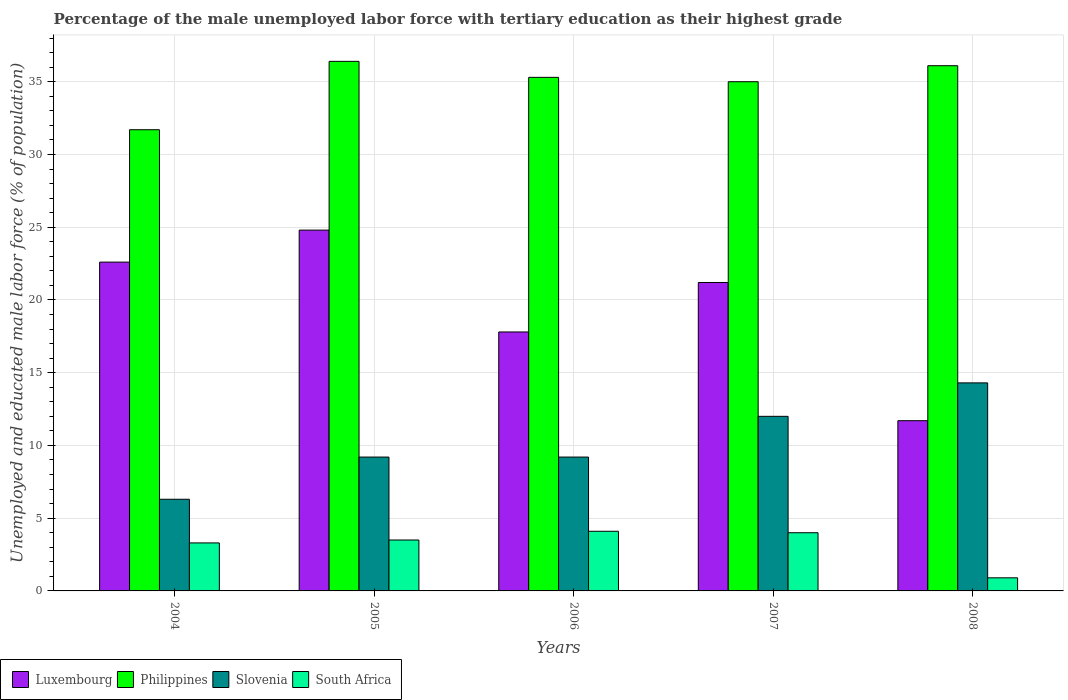How many different coloured bars are there?
Provide a succinct answer. 4. How many groups of bars are there?
Offer a very short reply. 5. Are the number of bars per tick equal to the number of legend labels?
Offer a terse response. Yes. How many bars are there on the 5th tick from the right?
Offer a very short reply. 4. What is the percentage of the unemployed male labor force with tertiary education in Luxembourg in 2004?
Give a very brief answer. 22.6. Across all years, what is the maximum percentage of the unemployed male labor force with tertiary education in Slovenia?
Keep it short and to the point. 14.3. Across all years, what is the minimum percentage of the unemployed male labor force with tertiary education in Slovenia?
Provide a succinct answer. 6.3. In which year was the percentage of the unemployed male labor force with tertiary education in Philippines minimum?
Your response must be concise. 2004. What is the total percentage of the unemployed male labor force with tertiary education in Slovenia in the graph?
Offer a very short reply. 51. What is the difference between the percentage of the unemployed male labor force with tertiary education in Slovenia in 2007 and that in 2008?
Offer a very short reply. -2.3. What is the difference between the percentage of the unemployed male labor force with tertiary education in Philippines in 2005 and the percentage of the unemployed male labor force with tertiary education in South Africa in 2006?
Your response must be concise. 32.3. What is the average percentage of the unemployed male labor force with tertiary education in South Africa per year?
Keep it short and to the point. 3.16. In the year 2006, what is the difference between the percentage of the unemployed male labor force with tertiary education in Luxembourg and percentage of the unemployed male labor force with tertiary education in Philippines?
Offer a terse response. -17.5. In how many years, is the percentage of the unemployed male labor force with tertiary education in Philippines greater than 28 %?
Your response must be concise. 5. What is the ratio of the percentage of the unemployed male labor force with tertiary education in Luxembourg in 2006 to that in 2007?
Your answer should be compact. 0.84. What is the difference between the highest and the second highest percentage of the unemployed male labor force with tertiary education in Slovenia?
Ensure brevity in your answer.  2.3. What is the difference between the highest and the lowest percentage of the unemployed male labor force with tertiary education in Philippines?
Offer a terse response. 4.7. In how many years, is the percentage of the unemployed male labor force with tertiary education in South Africa greater than the average percentage of the unemployed male labor force with tertiary education in South Africa taken over all years?
Provide a short and direct response. 4. Is it the case that in every year, the sum of the percentage of the unemployed male labor force with tertiary education in Luxembourg and percentage of the unemployed male labor force with tertiary education in South Africa is greater than the sum of percentage of the unemployed male labor force with tertiary education in Slovenia and percentage of the unemployed male labor force with tertiary education in Philippines?
Your answer should be very brief. No. What does the 2nd bar from the left in 2005 represents?
Keep it short and to the point. Philippines. What does the 2nd bar from the right in 2004 represents?
Keep it short and to the point. Slovenia. How many legend labels are there?
Provide a succinct answer. 4. What is the title of the graph?
Make the answer very short. Percentage of the male unemployed labor force with tertiary education as their highest grade. What is the label or title of the Y-axis?
Ensure brevity in your answer.  Unemployed and educated male labor force (% of population). What is the Unemployed and educated male labor force (% of population) of Luxembourg in 2004?
Offer a terse response. 22.6. What is the Unemployed and educated male labor force (% of population) of Philippines in 2004?
Provide a short and direct response. 31.7. What is the Unemployed and educated male labor force (% of population) of Slovenia in 2004?
Your response must be concise. 6.3. What is the Unemployed and educated male labor force (% of population) in South Africa in 2004?
Your answer should be very brief. 3.3. What is the Unemployed and educated male labor force (% of population) in Luxembourg in 2005?
Offer a very short reply. 24.8. What is the Unemployed and educated male labor force (% of population) in Philippines in 2005?
Keep it short and to the point. 36.4. What is the Unemployed and educated male labor force (% of population) in Slovenia in 2005?
Your response must be concise. 9.2. What is the Unemployed and educated male labor force (% of population) of Luxembourg in 2006?
Make the answer very short. 17.8. What is the Unemployed and educated male labor force (% of population) in Philippines in 2006?
Your response must be concise. 35.3. What is the Unemployed and educated male labor force (% of population) of Slovenia in 2006?
Give a very brief answer. 9.2. What is the Unemployed and educated male labor force (% of population) in South Africa in 2006?
Provide a succinct answer. 4.1. What is the Unemployed and educated male labor force (% of population) of Luxembourg in 2007?
Your answer should be compact. 21.2. What is the Unemployed and educated male labor force (% of population) in Philippines in 2007?
Your answer should be compact. 35. What is the Unemployed and educated male labor force (% of population) of South Africa in 2007?
Offer a terse response. 4. What is the Unemployed and educated male labor force (% of population) of Luxembourg in 2008?
Keep it short and to the point. 11.7. What is the Unemployed and educated male labor force (% of population) of Philippines in 2008?
Offer a very short reply. 36.1. What is the Unemployed and educated male labor force (% of population) of Slovenia in 2008?
Ensure brevity in your answer.  14.3. What is the Unemployed and educated male labor force (% of population) of South Africa in 2008?
Provide a succinct answer. 0.9. Across all years, what is the maximum Unemployed and educated male labor force (% of population) in Luxembourg?
Give a very brief answer. 24.8. Across all years, what is the maximum Unemployed and educated male labor force (% of population) in Philippines?
Offer a terse response. 36.4. Across all years, what is the maximum Unemployed and educated male labor force (% of population) in Slovenia?
Ensure brevity in your answer.  14.3. Across all years, what is the maximum Unemployed and educated male labor force (% of population) in South Africa?
Offer a terse response. 4.1. Across all years, what is the minimum Unemployed and educated male labor force (% of population) in Luxembourg?
Keep it short and to the point. 11.7. Across all years, what is the minimum Unemployed and educated male labor force (% of population) of Philippines?
Ensure brevity in your answer.  31.7. Across all years, what is the minimum Unemployed and educated male labor force (% of population) of Slovenia?
Your answer should be compact. 6.3. Across all years, what is the minimum Unemployed and educated male labor force (% of population) of South Africa?
Your answer should be very brief. 0.9. What is the total Unemployed and educated male labor force (% of population) of Luxembourg in the graph?
Your answer should be compact. 98.1. What is the total Unemployed and educated male labor force (% of population) in Philippines in the graph?
Keep it short and to the point. 174.5. What is the total Unemployed and educated male labor force (% of population) of Slovenia in the graph?
Provide a short and direct response. 51. What is the total Unemployed and educated male labor force (% of population) of South Africa in the graph?
Your answer should be very brief. 15.8. What is the difference between the Unemployed and educated male labor force (% of population) of Luxembourg in 2004 and that in 2005?
Your response must be concise. -2.2. What is the difference between the Unemployed and educated male labor force (% of population) of Philippines in 2004 and that in 2006?
Provide a short and direct response. -3.6. What is the difference between the Unemployed and educated male labor force (% of population) of Slovenia in 2004 and that in 2006?
Give a very brief answer. -2.9. What is the difference between the Unemployed and educated male labor force (% of population) in South Africa in 2004 and that in 2006?
Provide a short and direct response. -0.8. What is the difference between the Unemployed and educated male labor force (% of population) of Luxembourg in 2004 and that in 2007?
Provide a succinct answer. 1.4. What is the difference between the Unemployed and educated male labor force (% of population) in Slovenia in 2004 and that in 2007?
Keep it short and to the point. -5.7. What is the difference between the Unemployed and educated male labor force (% of population) in Luxembourg in 2004 and that in 2008?
Ensure brevity in your answer.  10.9. What is the difference between the Unemployed and educated male labor force (% of population) in Slovenia in 2004 and that in 2008?
Give a very brief answer. -8. What is the difference between the Unemployed and educated male labor force (% of population) of South Africa in 2004 and that in 2008?
Offer a very short reply. 2.4. What is the difference between the Unemployed and educated male labor force (% of population) of Slovenia in 2005 and that in 2006?
Your answer should be compact. 0. What is the difference between the Unemployed and educated male labor force (% of population) in Slovenia in 2005 and that in 2007?
Your answer should be compact. -2.8. What is the difference between the Unemployed and educated male labor force (% of population) of South Africa in 2005 and that in 2007?
Ensure brevity in your answer.  -0.5. What is the difference between the Unemployed and educated male labor force (% of population) in Luxembourg in 2005 and that in 2008?
Provide a succinct answer. 13.1. What is the difference between the Unemployed and educated male labor force (% of population) in Philippines in 2005 and that in 2008?
Give a very brief answer. 0.3. What is the difference between the Unemployed and educated male labor force (% of population) of Slovenia in 2005 and that in 2008?
Offer a very short reply. -5.1. What is the difference between the Unemployed and educated male labor force (% of population) in Luxembourg in 2006 and that in 2007?
Ensure brevity in your answer.  -3.4. What is the difference between the Unemployed and educated male labor force (% of population) of Philippines in 2006 and that in 2007?
Keep it short and to the point. 0.3. What is the difference between the Unemployed and educated male labor force (% of population) of Luxembourg in 2006 and that in 2008?
Your answer should be very brief. 6.1. What is the difference between the Unemployed and educated male labor force (% of population) in Philippines in 2006 and that in 2008?
Offer a terse response. -0.8. What is the difference between the Unemployed and educated male labor force (% of population) of Luxembourg in 2007 and that in 2008?
Ensure brevity in your answer.  9.5. What is the difference between the Unemployed and educated male labor force (% of population) of Philippines in 2007 and that in 2008?
Your answer should be compact. -1.1. What is the difference between the Unemployed and educated male labor force (% of population) of South Africa in 2007 and that in 2008?
Make the answer very short. 3.1. What is the difference between the Unemployed and educated male labor force (% of population) of Luxembourg in 2004 and the Unemployed and educated male labor force (% of population) of Slovenia in 2005?
Make the answer very short. 13.4. What is the difference between the Unemployed and educated male labor force (% of population) in Philippines in 2004 and the Unemployed and educated male labor force (% of population) in South Africa in 2005?
Provide a succinct answer. 28.2. What is the difference between the Unemployed and educated male labor force (% of population) of Luxembourg in 2004 and the Unemployed and educated male labor force (% of population) of Slovenia in 2006?
Your answer should be compact. 13.4. What is the difference between the Unemployed and educated male labor force (% of population) of Luxembourg in 2004 and the Unemployed and educated male labor force (% of population) of South Africa in 2006?
Offer a very short reply. 18.5. What is the difference between the Unemployed and educated male labor force (% of population) in Philippines in 2004 and the Unemployed and educated male labor force (% of population) in Slovenia in 2006?
Your answer should be compact. 22.5. What is the difference between the Unemployed and educated male labor force (% of population) of Philippines in 2004 and the Unemployed and educated male labor force (% of population) of South Africa in 2006?
Your response must be concise. 27.6. What is the difference between the Unemployed and educated male labor force (% of population) of Slovenia in 2004 and the Unemployed and educated male labor force (% of population) of South Africa in 2006?
Ensure brevity in your answer.  2.2. What is the difference between the Unemployed and educated male labor force (% of population) of Luxembourg in 2004 and the Unemployed and educated male labor force (% of population) of Philippines in 2007?
Keep it short and to the point. -12.4. What is the difference between the Unemployed and educated male labor force (% of population) in Philippines in 2004 and the Unemployed and educated male labor force (% of population) in South Africa in 2007?
Offer a terse response. 27.7. What is the difference between the Unemployed and educated male labor force (% of population) in Luxembourg in 2004 and the Unemployed and educated male labor force (% of population) in Slovenia in 2008?
Your response must be concise. 8.3. What is the difference between the Unemployed and educated male labor force (% of population) in Luxembourg in 2004 and the Unemployed and educated male labor force (% of population) in South Africa in 2008?
Offer a terse response. 21.7. What is the difference between the Unemployed and educated male labor force (% of population) of Philippines in 2004 and the Unemployed and educated male labor force (% of population) of South Africa in 2008?
Offer a terse response. 30.8. What is the difference between the Unemployed and educated male labor force (% of population) in Luxembourg in 2005 and the Unemployed and educated male labor force (% of population) in Slovenia in 2006?
Offer a very short reply. 15.6. What is the difference between the Unemployed and educated male labor force (% of population) in Luxembourg in 2005 and the Unemployed and educated male labor force (% of population) in South Africa in 2006?
Provide a succinct answer. 20.7. What is the difference between the Unemployed and educated male labor force (% of population) of Philippines in 2005 and the Unemployed and educated male labor force (% of population) of Slovenia in 2006?
Provide a short and direct response. 27.2. What is the difference between the Unemployed and educated male labor force (% of population) of Philippines in 2005 and the Unemployed and educated male labor force (% of population) of South Africa in 2006?
Keep it short and to the point. 32.3. What is the difference between the Unemployed and educated male labor force (% of population) in Slovenia in 2005 and the Unemployed and educated male labor force (% of population) in South Africa in 2006?
Your answer should be compact. 5.1. What is the difference between the Unemployed and educated male labor force (% of population) of Luxembourg in 2005 and the Unemployed and educated male labor force (% of population) of Philippines in 2007?
Your answer should be very brief. -10.2. What is the difference between the Unemployed and educated male labor force (% of population) of Luxembourg in 2005 and the Unemployed and educated male labor force (% of population) of Slovenia in 2007?
Ensure brevity in your answer.  12.8. What is the difference between the Unemployed and educated male labor force (% of population) in Luxembourg in 2005 and the Unemployed and educated male labor force (% of population) in South Africa in 2007?
Your response must be concise. 20.8. What is the difference between the Unemployed and educated male labor force (% of population) in Philippines in 2005 and the Unemployed and educated male labor force (% of population) in Slovenia in 2007?
Provide a succinct answer. 24.4. What is the difference between the Unemployed and educated male labor force (% of population) in Philippines in 2005 and the Unemployed and educated male labor force (% of population) in South Africa in 2007?
Make the answer very short. 32.4. What is the difference between the Unemployed and educated male labor force (% of population) of Slovenia in 2005 and the Unemployed and educated male labor force (% of population) of South Africa in 2007?
Provide a short and direct response. 5.2. What is the difference between the Unemployed and educated male labor force (% of population) in Luxembourg in 2005 and the Unemployed and educated male labor force (% of population) in South Africa in 2008?
Offer a very short reply. 23.9. What is the difference between the Unemployed and educated male labor force (% of population) of Philippines in 2005 and the Unemployed and educated male labor force (% of population) of Slovenia in 2008?
Ensure brevity in your answer.  22.1. What is the difference between the Unemployed and educated male labor force (% of population) in Philippines in 2005 and the Unemployed and educated male labor force (% of population) in South Africa in 2008?
Give a very brief answer. 35.5. What is the difference between the Unemployed and educated male labor force (% of population) of Slovenia in 2005 and the Unemployed and educated male labor force (% of population) of South Africa in 2008?
Offer a very short reply. 8.3. What is the difference between the Unemployed and educated male labor force (% of population) in Luxembourg in 2006 and the Unemployed and educated male labor force (% of population) in Philippines in 2007?
Offer a terse response. -17.2. What is the difference between the Unemployed and educated male labor force (% of population) in Luxembourg in 2006 and the Unemployed and educated male labor force (% of population) in Slovenia in 2007?
Your answer should be compact. 5.8. What is the difference between the Unemployed and educated male labor force (% of population) of Luxembourg in 2006 and the Unemployed and educated male labor force (% of population) of South Africa in 2007?
Provide a succinct answer. 13.8. What is the difference between the Unemployed and educated male labor force (% of population) of Philippines in 2006 and the Unemployed and educated male labor force (% of population) of Slovenia in 2007?
Offer a terse response. 23.3. What is the difference between the Unemployed and educated male labor force (% of population) in Philippines in 2006 and the Unemployed and educated male labor force (% of population) in South Africa in 2007?
Provide a succinct answer. 31.3. What is the difference between the Unemployed and educated male labor force (% of population) in Luxembourg in 2006 and the Unemployed and educated male labor force (% of population) in Philippines in 2008?
Your answer should be very brief. -18.3. What is the difference between the Unemployed and educated male labor force (% of population) in Luxembourg in 2006 and the Unemployed and educated male labor force (% of population) in Slovenia in 2008?
Give a very brief answer. 3.5. What is the difference between the Unemployed and educated male labor force (% of population) of Philippines in 2006 and the Unemployed and educated male labor force (% of population) of Slovenia in 2008?
Provide a short and direct response. 21. What is the difference between the Unemployed and educated male labor force (% of population) in Philippines in 2006 and the Unemployed and educated male labor force (% of population) in South Africa in 2008?
Provide a short and direct response. 34.4. What is the difference between the Unemployed and educated male labor force (% of population) of Luxembourg in 2007 and the Unemployed and educated male labor force (% of population) of Philippines in 2008?
Give a very brief answer. -14.9. What is the difference between the Unemployed and educated male labor force (% of population) of Luxembourg in 2007 and the Unemployed and educated male labor force (% of population) of Slovenia in 2008?
Your response must be concise. 6.9. What is the difference between the Unemployed and educated male labor force (% of population) in Luxembourg in 2007 and the Unemployed and educated male labor force (% of population) in South Africa in 2008?
Provide a succinct answer. 20.3. What is the difference between the Unemployed and educated male labor force (% of population) of Philippines in 2007 and the Unemployed and educated male labor force (% of population) of Slovenia in 2008?
Offer a very short reply. 20.7. What is the difference between the Unemployed and educated male labor force (% of population) in Philippines in 2007 and the Unemployed and educated male labor force (% of population) in South Africa in 2008?
Provide a succinct answer. 34.1. What is the average Unemployed and educated male labor force (% of population) of Luxembourg per year?
Your answer should be compact. 19.62. What is the average Unemployed and educated male labor force (% of population) in Philippines per year?
Provide a short and direct response. 34.9. What is the average Unemployed and educated male labor force (% of population) in South Africa per year?
Give a very brief answer. 3.16. In the year 2004, what is the difference between the Unemployed and educated male labor force (% of population) in Luxembourg and Unemployed and educated male labor force (% of population) in South Africa?
Your answer should be compact. 19.3. In the year 2004, what is the difference between the Unemployed and educated male labor force (% of population) of Philippines and Unemployed and educated male labor force (% of population) of Slovenia?
Your answer should be very brief. 25.4. In the year 2004, what is the difference between the Unemployed and educated male labor force (% of population) in Philippines and Unemployed and educated male labor force (% of population) in South Africa?
Keep it short and to the point. 28.4. In the year 2004, what is the difference between the Unemployed and educated male labor force (% of population) of Slovenia and Unemployed and educated male labor force (% of population) of South Africa?
Offer a very short reply. 3. In the year 2005, what is the difference between the Unemployed and educated male labor force (% of population) of Luxembourg and Unemployed and educated male labor force (% of population) of Philippines?
Make the answer very short. -11.6. In the year 2005, what is the difference between the Unemployed and educated male labor force (% of population) in Luxembourg and Unemployed and educated male labor force (% of population) in South Africa?
Provide a succinct answer. 21.3. In the year 2005, what is the difference between the Unemployed and educated male labor force (% of population) in Philippines and Unemployed and educated male labor force (% of population) in Slovenia?
Your answer should be compact. 27.2. In the year 2005, what is the difference between the Unemployed and educated male labor force (% of population) of Philippines and Unemployed and educated male labor force (% of population) of South Africa?
Make the answer very short. 32.9. In the year 2005, what is the difference between the Unemployed and educated male labor force (% of population) in Slovenia and Unemployed and educated male labor force (% of population) in South Africa?
Keep it short and to the point. 5.7. In the year 2006, what is the difference between the Unemployed and educated male labor force (% of population) of Luxembourg and Unemployed and educated male labor force (% of population) of Philippines?
Make the answer very short. -17.5. In the year 2006, what is the difference between the Unemployed and educated male labor force (% of population) in Luxembourg and Unemployed and educated male labor force (% of population) in Slovenia?
Give a very brief answer. 8.6. In the year 2006, what is the difference between the Unemployed and educated male labor force (% of population) of Philippines and Unemployed and educated male labor force (% of population) of Slovenia?
Provide a succinct answer. 26.1. In the year 2006, what is the difference between the Unemployed and educated male labor force (% of population) of Philippines and Unemployed and educated male labor force (% of population) of South Africa?
Keep it short and to the point. 31.2. In the year 2006, what is the difference between the Unemployed and educated male labor force (% of population) of Slovenia and Unemployed and educated male labor force (% of population) of South Africa?
Your answer should be compact. 5.1. In the year 2007, what is the difference between the Unemployed and educated male labor force (% of population) in Luxembourg and Unemployed and educated male labor force (% of population) in Philippines?
Your answer should be very brief. -13.8. In the year 2007, what is the difference between the Unemployed and educated male labor force (% of population) in Luxembourg and Unemployed and educated male labor force (% of population) in Slovenia?
Your answer should be compact. 9.2. In the year 2007, what is the difference between the Unemployed and educated male labor force (% of population) of Philippines and Unemployed and educated male labor force (% of population) of Slovenia?
Offer a very short reply. 23. In the year 2007, what is the difference between the Unemployed and educated male labor force (% of population) of Philippines and Unemployed and educated male labor force (% of population) of South Africa?
Your response must be concise. 31. In the year 2008, what is the difference between the Unemployed and educated male labor force (% of population) of Luxembourg and Unemployed and educated male labor force (% of population) of Philippines?
Provide a succinct answer. -24.4. In the year 2008, what is the difference between the Unemployed and educated male labor force (% of population) in Philippines and Unemployed and educated male labor force (% of population) in Slovenia?
Your answer should be compact. 21.8. In the year 2008, what is the difference between the Unemployed and educated male labor force (% of population) of Philippines and Unemployed and educated male labor force (% of population) of South Africa?
Provide a succinct answer. 35.2. In the year 2008, what is the difference between the Unemployed and educated male labor force (% of population) of Slovenia and Unemployed and educated male labor force (% of population) of South Africa?
Keep it short and to the point. 13.4. What is the ratio of the Unemployed and educated male labor force (% of population) in Luxembourg in 2004 to that in 2005?
Offer a terse response. 0.91. What is the ratio of the Unemployed and educated male labor force (% of population) in Philippines in 2004 to that in 2005?
Your answer should be very brief. 0.87. What is the ratio of the Unemployed and educated male labor force (% of population) in Slovenia in 2004 to that in 2005?
Your answer should be very brief. 0.68. What is the ratio of the Unemployed and educated male labor force (% of population) of South Africa in 2004 to that in 2005?
Give a very brief answer. 0.94. What is the ratio of the Unemployed and educated male labor force (% of population) of Luxembourg in 2004 to that in 2006?
Offer a terse response. 1.27. What is the ratio of the Unemployed and educated male labor force (% of population) in Philippines in 2004 to that in 2006?
Offer a very short reply. 0.9. What is the ratio of the Unemployed and educated male labor force (% of population) in Slovenia in 2004 to that in 2006?
Your answer should be very brief. 0.68. What is the ratio of the Unemployed and educated male labor force (% of population) of South Africa in 2004 to that in 2006?
Your answer should be compact. 0.8. What is the ratio of the Unemployed and educated male labor force (% of population) of Luxembourg in 2004 to that in 2007?
Provide a short and direct response. 1.07. What is the ratio of the Unemployed and educated male labor force (% of population) of Philippines in 2004 to that in 2007?
Your answer should be very brief. 0.91. What is the ratio of the Unemployed and educated male labor force (% of population) in Slovenia in 2004 to that in 2007?
Offer a terse response. 0.53. What is the ratio of the Unemployed and educated male labor force (% of population) in South Africa in 2004 to that in 2007?
Keep it short and to the point. 0.82. What is the ratio of the Unemployed and educated male labor force (% of population) in Luxembourg in 2004 to that in 2008?
Your answer should be compact. 1.93. What is the ratio of the Unemployed and educated male labor force (% of population) of Philippines in 2004 to that in 2008?
Offer a terse response. 0.88. What is the ratio of the Unemployed and educated male labor force (% of population) in Slovenia in 2004 to that in 2008?
Offer a very short reply. 0.44. What is the ratio of the Unemployed and educated male labor force (% of population) of South Africa in 2004 to that in 2008?
Offer a terse response. 3.67. What is the ratio of the Unemployed and educated male labor force (% of population) of Luxembourg in 2005 to that in 2006?
Your answer should be very brief. 1.39. What is the ratio of the Unemployed and educated male labor force (% of population) in Philippines in 2005 to that in 2006?
Your response must be concise. 1.03. What is the ratio of the Unemployed and educated male labor force (% of population) in South Africa in 2005 to that in 2006?
Your answer should be compact. 0.85. What is the ratio of the Unemployed and educated male labor force (% of population) in Luxembourg in 2005 to that in 2007?
Ensure brevity in your answer.  1.17. What is the ratio of the Unemployed and educated male labor force (% of population) of Philippines in 2005 to that in 2007?
Offer a terse response. 1.04. What is the ratio of the Unemployed and educated male labor force (% of population) of Slovenia in 2005 to that in 2007?
Keep it short and to the point. 0.77. What is the ratio of the Unemployed and educated male labor force (% of population) of South Africa in 2005 to that in 2007?
Provide a succinct answer. 0.88. What is the ratio of the Unemployed and educated male labor force (% of population) of Luxembourg in 2005 to that in 2008?
Your answer should be very brief. 2.12. What is the ratio of the Unemployed and educated male labor force (% of population) in Philippines in 2005 to that in 2008?
Provide a short and direct response. 1.01. What is the ratio of the Unemployed and educated male labor force (% of population) of Slovenia in 2005 to that in 2008?
Offer a very short reply. 0.64. What is the ratio of the Unemployed and educated male labor force (% of population) in South Africa in 2005 to that in 2008?
Provide a succinct answer. 3.89. What is the ratio of the Unemployed and educated male labor force (% of population) in Luxembourg in 2006 to that in 2007?
Your answer should be very brief. 0.84. What is the ratio of the Unemployed and educated male labor force (% of population) in Philippines in 2006 to that in 2007?
Ensure brevity in your answer.  1.01. What is the ratio of the Unemployed and educated male labor force (% of population) in Slovenia in 2006 to that in 2007?
Your answer should be very brief. 0.77. What is the ratio of the Unemployed and educated male labor force (% of population) of Luxembourg in 2006 to that in 2008?
Provide a succinct answer. 1.52. What is the ratio of the Unemployed and educated male labor force (% of population) in Philippines in 2006 to that in 2008?
Give a very brief answer. 0.98. What is the ratio of the Unemployed and educated male labor force (% of population) of Slovenia in 2006 to that in 2008?
Offer a terse response. 0.64. What is the ratio of the Unemployed and educated male labor force (% of population) of South Africa in 2006 to that in 2008?
Keep it short and to the point. 4.56. What is the ratio of the Unemployed and educated male labor force (% of population) in Luxembourg in 2007 to that in 2008?
Provide a succinct answer. 1.81. What is the ratio of the Unemployed and educated male labor force (% of population) of Philippines in 2007 to that in 2008?
Keep it short and to the point. 0.97. What is the ratio of the Unemployed and educated male labor force (% of population) of Slovenia in 2007 to that in 2008?
Your response must be concise. 0.84. What is the ratio of the Unemployed and educated male labor force (% of population) in South Africa in 2007 to that in 2008?
Provide a short and direct response. 4.44. What is the difference between the highest and the second highest Unemployed and educated male labor force (% of population) of Luxembourg?
Provide a succinct answer. 2.2. What is the difference between the highest and the second highest Unemployed and educated male labor force (% of population) of Slovenia?
Your answer should be very brief. 2.3. What is the difference between the highest and the second highest Unemployed and educated male labor force (% of population) in South Africa?
Your answer should be very brief. 0.1. What is the difference between the highest and the lowest Unemployed and educated male labor force (% of population) in Luxembourg?
Give a very brief answer. 13.1. 